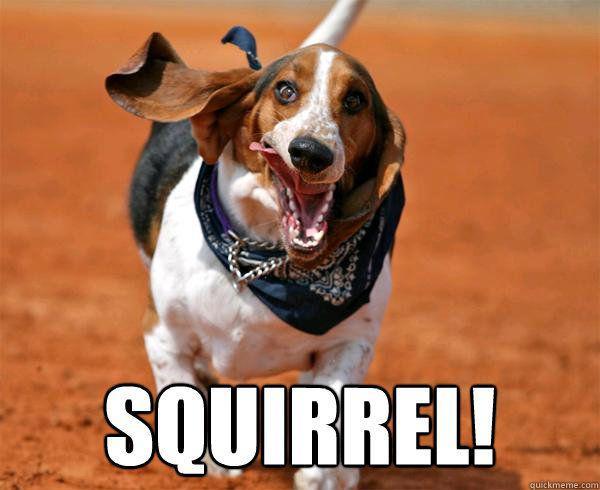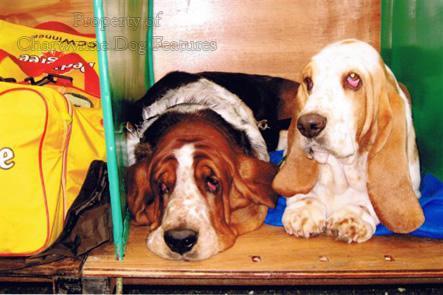The first image is the image on the left, the second image is the image on the right. Examine the images to the left and right. Is the description "There are fewer than four hounds here." accurate? Answer yes or no. Yes. The first image is the image on the left, the second image is the image on the right. Given the left and right images, does the statement "At least one dog is resting its head." hold true? Answer yes or no. Yes. 